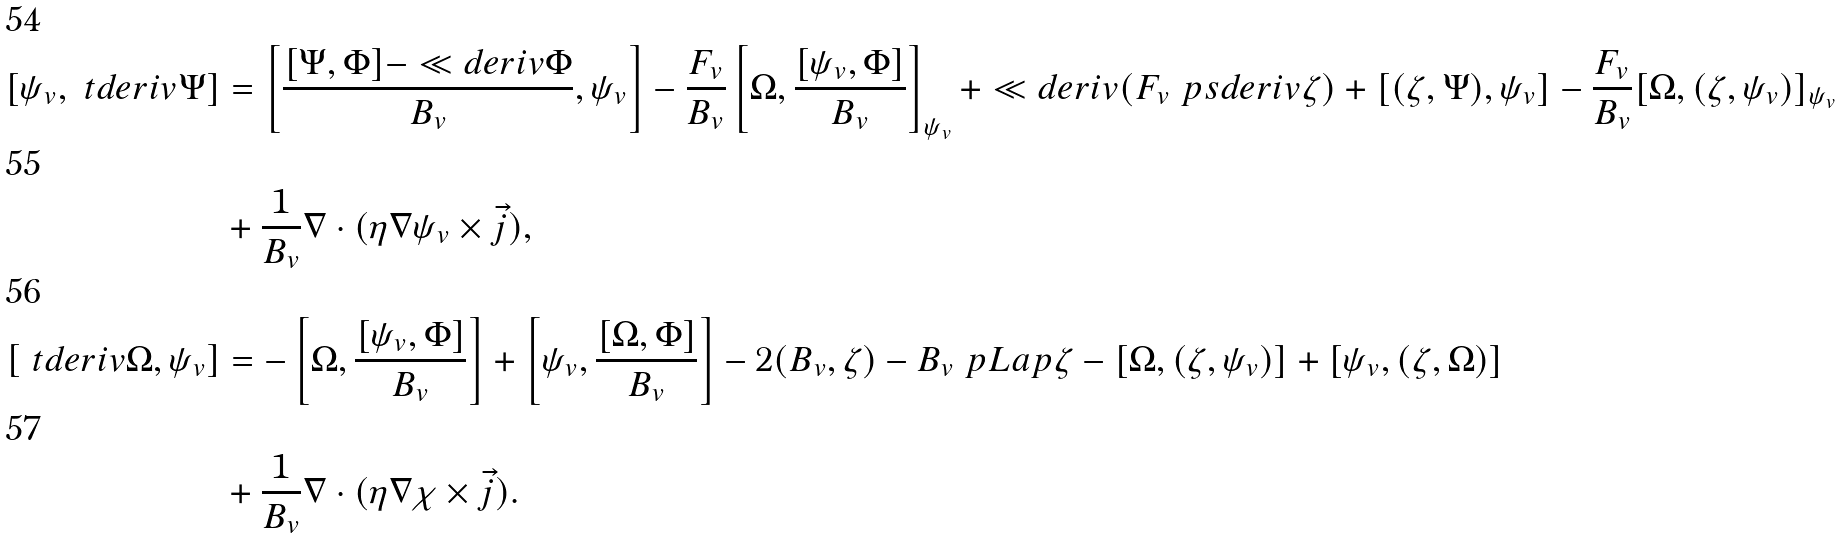Convert formula to latex. <formula><loc_0><loc_0><loc_500><loc_500>\left [ \psi _ { v } , \ t d e r i v { \Psi } \right ] & = \left [ \frac { [ \Psi , \Phi ] - \ll d e r i v \Phi } { B _ { v } } , \psi _ { v } \right ] - \frac { F _ { v } } { B _ { v } } \left [ \Omega , \frac { [ \psi _ { v } , \Phi ] } { B _ { v } } \right ] _ { \psi _ { v } } + \ll d e r i v ( F _ { v } \ p s d e r i v \zeta ) + [ ( \zeta , \Psi ) , \psi _ { v } ] - \frac { F _ { v } } { B _ { v } } [ \Omega , ( \zeta , \psi _ { v } ) ] _ { \psi _ { v } } \\ & + \frac { 1 } { B _ { v } } \nabla \cdot ( \eta \nabla \psi _ { v } \times \vec { j } ) , \\ \left [ \ t d e r i v { \Omega } , \psi _ { v } \right ] & = - \left [ \Omega , \frac { [ \psi _ { v } , \Phi ] } { B _ { v } } \right ] + \left [ \psi _ { v } , \frac { [ \Omega , \Phi ] } { B _ { v } } \right ] - 2 ( B _ { v } , \zeta ) - B _ { v } \ p L a p \zeta - [ \Omega , ( \zeta , \psi _ { v } ) ] + [ \psi _ { v } , ( \zeta , \Omega ) ] \\ & + \frac { 1 } { B _ { v } } \nabla \cdot ( \eta \nabla \chi \times \vec { j } ) .</formula> 